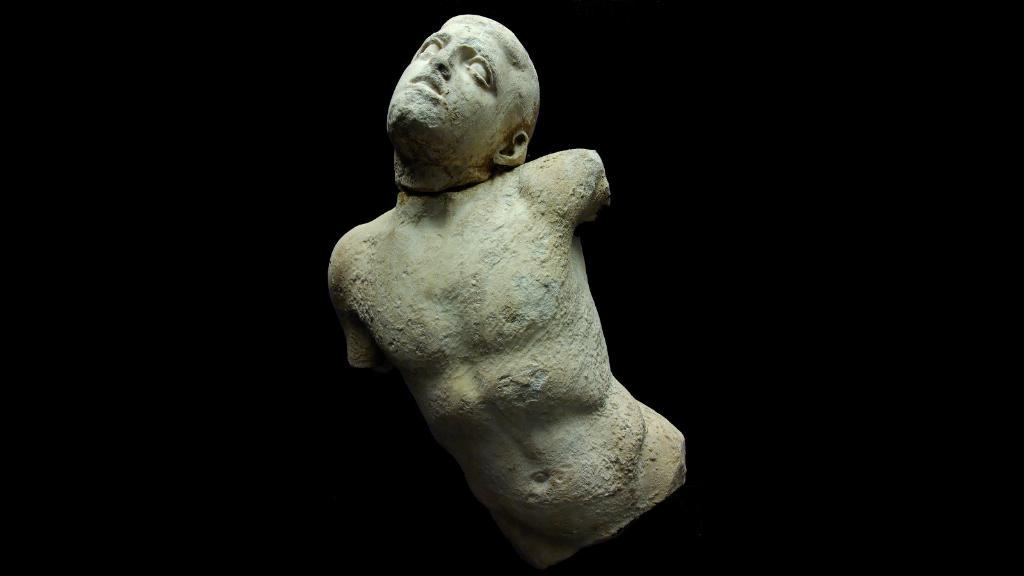What is the main subject of the image? There is a sculpture in the image. What is the sculpture depicting? The sculpture is of a human body. What specific features are missing from the sculpture? The sculpture does not have legs or hands. How is the head of the sculpture positioned? The sculpture has a head that is bent. What type of corn can be seen growing near the sculpture in the image? There is no corn present in the image; it only features a sculpture of a human body. Can you tell me how many dinosaurs are interacting with the sculpture in the image? There are no dinosaurs present in the image; it only features a sculpture of a human body. 